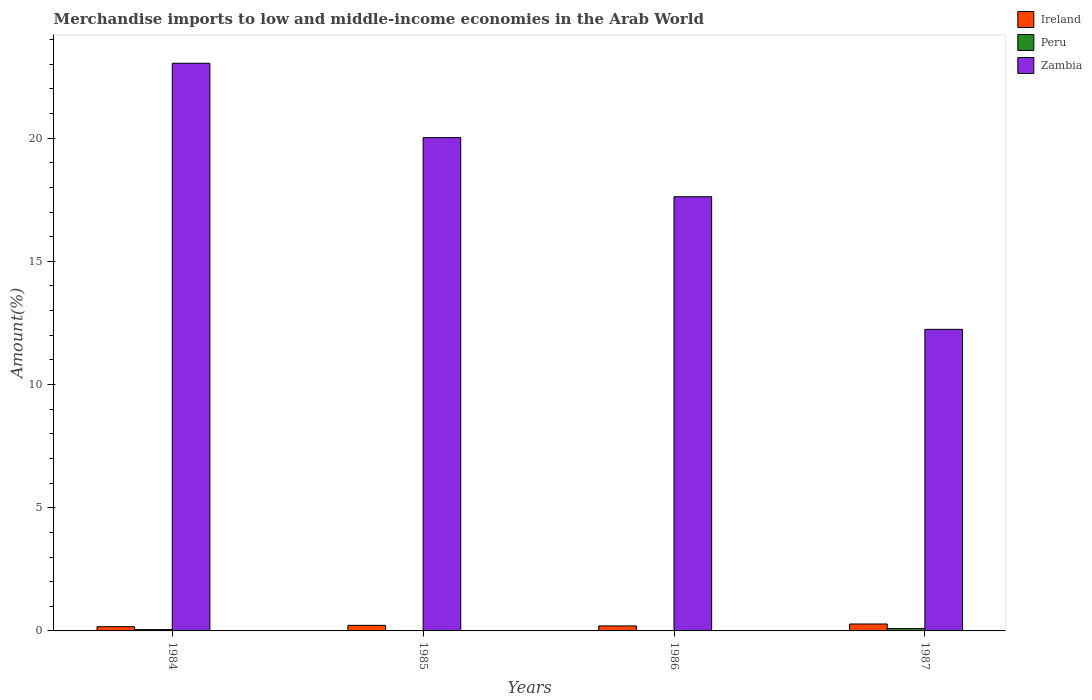How many groups of bars are there?
Your answer should be very brief. 4. Are the number of bars per tick equal to the number of legend labels?
Ensure brevity in your answer.  Yes. How many bars are there on the 1st tick from the left?
Your answer should be compact. 3. What is the label of the 3rd group of bars from the left?
Keep it short and to the point. 1986. What is the percentage of amount earned from merchandise imports in Zambia in 1986?
Give a very brief answer. 17.62. Across all years, what is the maximum percentage of amount earned from merchandise imports in Ireland?
Give a very brief answer. 0.28. Across all years, what is the minimum percentage of amount earned from merchandise imports in Zambia?
Give a very brief answer. 12.24. What is the total percentage of amount earned from merchandise imports in Zambia in the graph?
Provide a short and direct response. 72.92. What is the difference between the percentage of amount earned from merchandise imports in Zambia in 1984 and that in 1985?
Make the answer very short. 3.02. What is the difference between the percentage of amount earned from merchandise imports in Zambia in 1986 and the percentage of amount earned from merchandise imports in Peru in 1985?
Make the answer very short. 17.62. What is the average percentage of amount earned from merchandise imports in Zambia per year?
Ensure brevity in your answer.  18.23. In the year 1984, what is the difference between the percentage of amount earned from merchandise imports in Zambia and percentage of amount earned from merchandise imports in Ireland?
Give a very brief answer. 22.87. What is the ratio of the percentage of amount earned from merchandise imports in Peru in 1984 to that in 1987?
Keep it short and to the point. 0.55. Is the percentage of amount earned from merchandise imports in Peru in 1984 less than that in 1987?
Provide a short and direct response. Yes. Is the difference between the percentage of amount earned from merchandise imports in Zambia in 1984 and 1985 greater than the difference between the percentage of amount earned from merchandise imports in Ireland in 1984 and 1985?
Provide a short and direct response. Yes. What is the difference between the highest and the second highest percentage of amount earned from merchandise imports in Zambia?
Give a very brief answer. 3.02. What is the difference between the highest and the lowest percentage of amount earned from merchandise imports in Peru?
Give a very brief answer. 0.09. In how many years, is the percentage of amount earned from merchandise imports in Zambia greater than the average percentage of amount earned from merchandise imports in Zambia taken over all years?
Your answer should be compact. 2. Is the sum of the percentage of amount earned from merchandise imports in Zambia in 1986 and 1987 greater than the maximum percentage of amount earned from merchandise imports in Peru across all years?
Offer a terse response. Yes. What does the 1st bar from the left in 1986 represents?
Offer a very short reply. Ireland. What does the 2nd bar from the right in 1985 represents?
Offer a terse response. Peru. What is the difference between two consecutive major ticks on the Y-axis?
Your answer should be compact. 5. Are the values on the major ticks of Y-axis written in scientific E-notation?
Keep it short and to the point. No. Where does the legend appear in the graph?
Your response must be concise. Top right. How many legend labels are there?
Provide a succinct answer. 3. How are the legend labels stacked?
Provide a succinct answer. Vertical. What is the title of the graph?
Offer a very short reply. Merchandise imports to low and middle-income economies in the Arab World. What is the label or title of the Y-axis?
Your response must be concise. Amount(%). What is the Amount(%) of Ireland in 1984?
Make the answer very short. 0.17. What is the Amount(%) of Peru in 1984?
Provide a succinct answer. 0.05. What is the Amount(%) in Zambia in 1984?
Keep it short and to the point. 23.04. What is the Amount(%) of Ireland in 1985?
Offer a very short reply. 0.23. What is the Amount(%) of Peru in 1985?
Make the answer very short. 0.01. What is the Amount(%) in Zambia in 1985?
Your answer should be very brief. 20.02. What is the Amount(%) in Ireland in 1986?
Make the answer very short. 0.2. What is the Amount(%) of Peru in 1986?
Give a very brief answer. 0.01. What is the Amount(%) in Zambia in 1986?
Provide a succinct answer. 17.62. What is the Amount(%) in Ireland in 1987?
Provide a succinct answer. 0.28. What is the Amount(%) of Peru in 1987?
Your response must be concise. 0.1. What is the Amount(%) in Zambia in 1987?
Give a very brief answer. 12.24. Across all years, what is the maximum Amount(%) in Ireland?
Your answer should be compact. 0.28. Across all years, what is the maximum Amount(%) of Peru?
Provide a succinct answer. 0.1. Across all years, what is the maximum Amount(%) in Zambia?
Provide a succinct answer. 23.04. Across all years, what is the minimum Amount(%) in Ireland?
Your answer should be very brief. 0.17. Across all years, what is the minimum Amount(%) of Peru?
Keep it short and to the point. 0.01. Across all years, what is the minimum Amount(%) in Zambia?
Your answer should be very brief. 12.24. What is the total Amount(%) of Ireland in the graph?
Offer a very short reply. 0.88. What is the total Amount(%) of Peru in the graph?
Your response must be concise. 0.17. What is the total Amount(%) in Zambia in the graph?
Your answer should be very brief. 72.92. What is the difference between the Amount(%) of Ireland in 1984 and that in 1985?
Ensure brevity in your answer.  -0.05. What is the difference between the Amount(%) of Peru in 1984 and that in 1985?
Ensure brevity in your answer.  0.05. What is the difference between the Amount(%) of Zambia in 1984 and that in 1985?
Your answer should be compact. 3.02. What is the difference between the Amount(%) of Ireland in 1984 and that in 1986?
Keep it short and to the point. -0.03. What is the difference between the Amount(%) in Peru in 1984 and that in 1986?
Ensure brevity in your answer.  0.04. What is the difference between the Amount(%) of Zambia in 1984 and that in 1986?
Offer a very short reply. 5.42. What is the difference between the Amount(%) of Ireland in 1984 and that in 1987?
Your answer should be compact. -0.11. What is the difference between the Amount(%) in Peru in 1984 and that in 1987?
Offer a very short reply. -0.04. What is the difference between the Amount(%) in Zambia in 1984 and that in 1987?
Offer a very short reply. 10.8. What is the difference between the Amount(%) in Ireland in 1985 and that in 1986?
Provide a succinct answer. 0.02. What is the difference between the Amount(%) of Peru in 1985 and that in 1986?
Ensure brevity in your answer.  -0.01. What is the difference between the Amount(%) in Zambia in 1985 and that in 1986?
Give a very brief answer. 2.4. What is the difference between the Amount(%) of Ireland in 1985 and that in 1987?
Offer a very short reply. -0.06. What is the difference between the Amount(%) of Peru in 1985 and that in 1987?
Make the answer very short. -0.09. What is the difference between the Amount(%) in Zambia in 1985 and that in 1987?
Offer a terse response. 7.78. What is the difference between the Amount(%) of Ireland in 1986 and that in 1987?
Provide a succinct answer. -0.08. What is the difference between the Amount(%) in Peru in 1986 and that in 1987?
Offer a terse response. -0.08. What is the difference between the Amount(%) in Zambia in 1986 and that in 1987?
Keep it short and to the point. 5.38. What is the difference between the Amount(%) of Ireland in 1984 and the Amount(%) of Zambia in 1985?
Ensure brevity in your answer.  -19.85. What is the difference between the Amount(%) of Peru in 1984 and the Amount(%) of Zambia in 1985?
Provide a succinct answer. -19.97. What is the difference between the Amount(%) in Ireland in 1984 and the Amount(%) in Peru in 1986?
Make the answer very short. 0.16. What is the difference between the Amount(%) in Ireland in 1984 and the Amount(%) in Zambia in 1986?
Your answer should be compact. -17.45. What is the difference between the Amount(%) of Peru in 1984 and the Amount(%) of Zambia in 1986?
Give a very brief answer. -17.57. What is the difference between the Amount(%) in Ireland in 1984 and the Amount(%) in Peru in 1987?
Offer a very short reply. 0.08. What is the difference between the Amount(%) in Ireland in 1984 and the Amount(%) in Zambia in 1987?
Ensure brevity in your answer.  -12.07. What is the difference between the Amount(%) of Peru in 1984 and the Amount(%) of Zambia in 1987?
Your answer should be very brief. -12.19. What is the difference between the Amount(%) of Ireland in 1985 and the Amount(%) of Peru in 1986?
Give a very brief answer. 0.21. What is the difference between the Amount(%) in Ireland in 1985 and the Amount(%) in Zambia in 1986?
Your response must be concise. -17.4. What is the difference between the Amount(%) of Peru in 1985 and the Amount(%) of Zambia in 1986?
Ensure brevity in your answer.  -17.62. What is the difference between the Amount(%) of Ireland in 1985 and the Amount(%) of Peru in 1987?
Provide a succinct answer. 0.13. What is the difference between the Amount(%) in Ireland in 1985 and the Amount(%) in Zambia in 1987?
Provide a short and direct response. -12.01. What is the difference between the Amount(%) of Peru in 1985 and the Amount(%) of Zambia in 1987?
Your response must be concise. -12.23. What is the difference between the Amount(%) of Ireland in 1986 and the Amount(%) of Peru in 1987?
Offer a very short reply. 0.11. What is the difference between the Amount(%) of Ireland in 1986 and the Amount(%) of Zambia in 1987?
Your answer should be compact. -12.04. What is the difference between the Amount(%) of Peru in 1986 and the Amount(%) of Zambia in 1987?
Offer a very short reply. -12.23. What is the average Amount(%) in Ireland per year?
Provide a short and direct response. 0.22. What is the average Amount(%) in Peru per year?
Ensure brevity in your answer.  0.04. What is the average Amount(%) of Zambia per year?
Give a very brief answer. 18.23. In the year 1984, what is the difference between the Amount(%) of Ireland and Amount(%) of Peru?
Make the answer very short. 0.12. In the year 1984, what is the difference between the Amount(%) in Ireland and Amount(%) in Zambia?
Provide a succinct answer. -22.87. In the year 1984, what is the difference between the Amount(%) of Peru and Amount(%) of Zambia?
Your answer should be compact. -22.99. In the year 1985, what is the difference between the Amount(%) of Ireland and Amount(%) of Peru?
Give a very brief answer. 0.22. In the year 1985, what is the difference between the Amount(%) of Ireland and Amount(%) of Zambia?
Provide a short and direct response. -19.79. In the year 1985, what is the difference between the Amount(%) in Peru and Amount(%) in Zambia?
Ensure brevity in your answer.  -20.02. In the year 1986, what is the difference between the Amount(%) in Ireland and Amount(%) in Peru?
Give a very brief answer. 0.19. In the year 1986, what is the difference between the Amount(%) in Ireland and Amount(%) in Zambia?
Ensure brevity in your answer.  -17.42. In the year 1986, what is the difference between the Amount(%) in Peru and Amount(%) in Zambia?
Your response must be concise. -17.61. In the year 1987, what is the difference between the Amount(%) in Ireland and Amount(%) in Peru?
Provide a short and direct response. 0.19. In the year 1987, what is the difference between the Amount(%) in Ireland and Amount(%) in Zambia?
Your response must be concise. -11.96. In the year 1987, what is the difference between the Amount(%) in Peru and Amount(%) in Zambia?
Your answer should be very brief. -12.14. What is the ratio of the Amount(%) of Ireland in 1984 to that in 1985?
Offer a very short reply. 0.76. What is the ratio of the Amount(%) in Peru in 1984 to that in 1985?
Your response must be concise. 10.38. What is the ratio of the Amount(%) in Zambia in 1984 to that in 1985?
Your response must be concise. 1.15. What is the ratio of the Amount(%) in Ireland in 1984 to that in 1986?
Make the answer very short. 0.84. What is the ratio of the Amount(%) of Peru in 1984 to that in 1986?
Your response must be concise. 3.9. What is the ratio of the Amount(%) in Zambia in 1984 to that in 1986?
Ensure brevity in your answer.  1.31. What is the ratio of the Amount(%) in Ireland in 1984 to that in 1987?
Your answer should be compact. 0.61. What is the ratio of the Amount(%) in Peru in 1984 to that in 1987?
Make the answer very short. 0.55. What is the ratio of the Amount(%) of Zambia in 1984 to that in 1987?
Your answer should be compact. 1.88. What is the ratio of the Amount(%) of Ireland in 1985 to that in 1986?
Give a very brief answer. 1.11. What is the ratio of the Amount(%) in Peru in 1985 to that in 1986?
Offer a very short reply. 0.38. What is the ratio of the Amount(%) in Zambia in 1985 to that in 1986?
Keep it short and to the point. 1.14. What is the ratio of the Amount(%) of Ireland in 1985 to that in 1987?
Your answer should be compact. 0.8. What is the ratio of the Amount(%) of Peru in 1985 to that in 1987?
Give a very brief answer. 0.05. What is the ratio of the Amount(%) of Zambia in 1985 to that in 1987?
Give a very brief answer. 1.64. What is the ratio of the Amount(%) of Ireland in 1986 to that in 1987?
Ensure brevity in your answer.  0.72. What is the ratio of the Amount(%) in Peru in 1986 to that in 1987?
Provide a succinct answer. 0.14. What is the ratio of the Amount(%) of Zambia in 1986 to that in 1987?
Provide a succinct answer. 1.44. What is the difference between the highest and the second highest Amount(%) of Ireland?
Offer a very short reply. 0.06. What is the difference between the highest and the second highest Amount(%) in Peru?
Your answer should be very brief. 0.04. What is the difference between the highest and the second highest Amount(%) of Zambia?
Make the answer very short. 3.02. What is the difference between the highest and the lowest Amount(%) in Ireland?
Your answer should be very brief. 0.11. What is the difference between the highest and the lowest Amount(%) in Peru?
Make the answer very short. 0.09. What is the difference between the highest and the lowest Amount(%) of Zambia?
Provide a succinct answer. 10.8. 